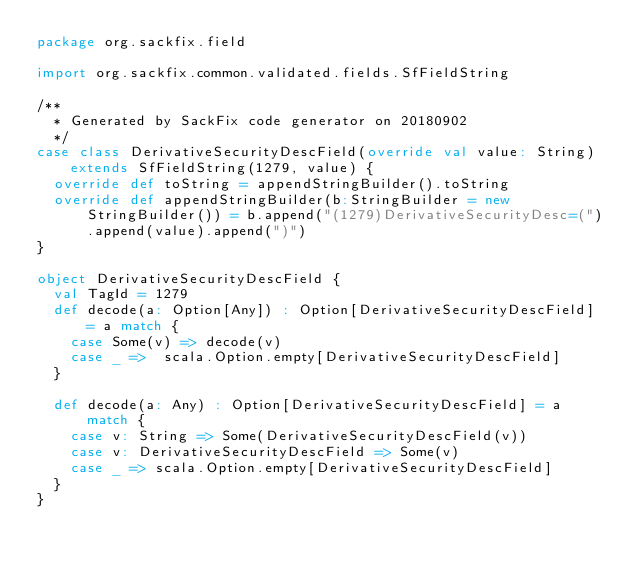<code> <loc_0><loc_0><loc_500><loc_500><_Scala_>package org.sackfix.field

import org.sackfix.common.validated.fields.SfFieldString

/**
  * Generated by SackFix code generator on 20180902
  */
case class DerivativeSecurityDescField(override val value: String) extends SfFieldString(1279, value) {
  override def toString = appendStringBuilder().toString
  override def appendStringBuilder(b:StringBuilder = new StringBuilder()) = b.append("(1279)DerivativeSecurityDesc=(").append(value).append(")")
}

object DerivativeSecurityDescField {
  val TagId = 1279  
  def decode(a: Option[Any]) : Option[DerivativeSecurityDescField] = a match {
    case Some(v) => decode(v)
    case _ =>  scala.Option.empty[DerivativeSecurityDescField]
  }

  def decode(a: Any) : Option[DerivativeSecurityDescField] = a match {
    case v: String => Some(DerivativeSecurityDescField(v))
    case v: DerivativeSecurityDescField => Some(v)
    case _ => scala.Option.empty[DerivativeSecurityDescField]
  } 
}
</code> 